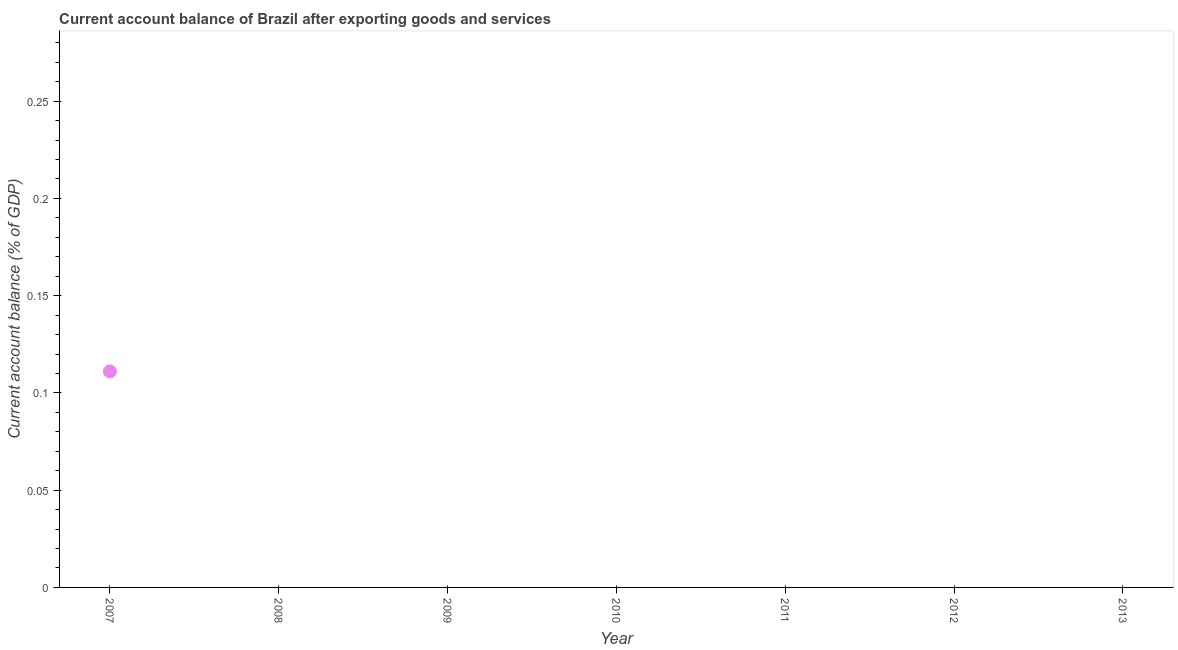Across all years, what is the maximum current account balance?
Ensure brevity in your answer.  0.11. Across all years, what is the minimum current account balance?
Offer a very short reply. 0. What is the sum of the current account balance?
Your answer should be compact. 0.11. What is the average current account balance per year?
Your answer should be compact. 0.02. What is the median current account balance?
Your response must be concise. 0. What is the difference between the highest and the lowest current account balance?
Your response must be concise. 0.11. In how many years, is the current account balance greater than the average current account balance taken over all years?
Your response must be concise. 1. How many dotlines are there?
Ensure brevity in your answer.  1. How many years are there in the graph?
Keep it short and to the point. 7. What is the difference between two consecutive major ticks on the Y-axis?
Offer a very short reply. 0.05. Are the values on the major ticks of Y-axis written in scientific E-notation?
Give a very brief answer. No. What is the title of the graph?
Keep it short and to the point. Current account balance of Brazil after exporting goods and services. What is the label or title of the Y-axis?
Provide a succinct answer. Current account balance (% of GDP). What is the Current account balance (% of GDP) in 2007?
Offer a terse response. 0.11. What is the Current account balance (% of GDP) in 2013?
Make the answer very short. 0. 